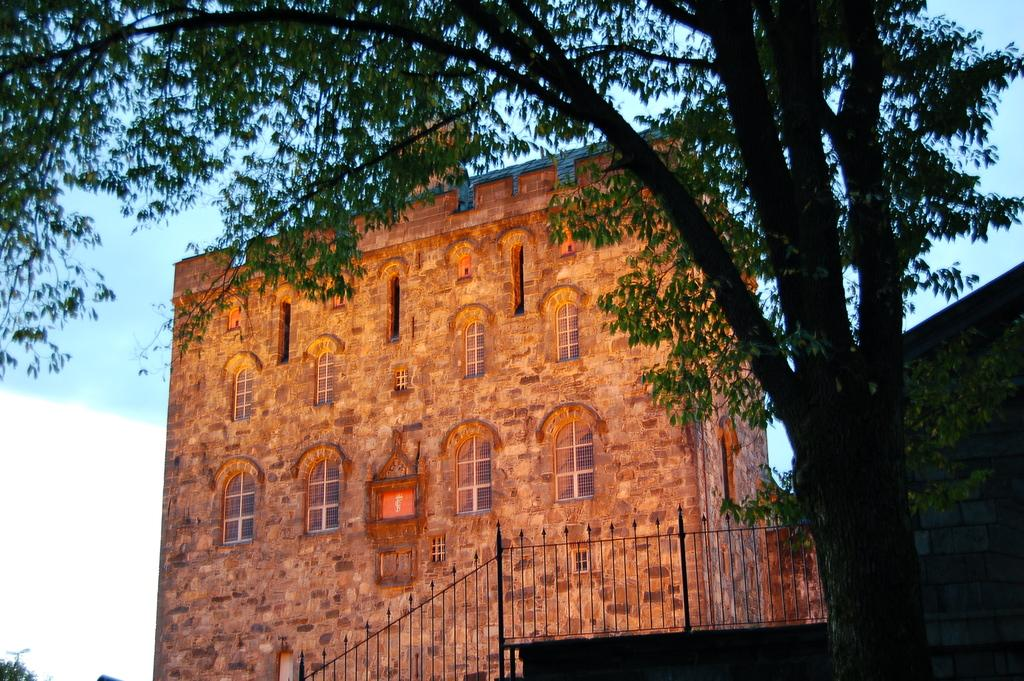What type of structure is present in the image? There is a building in the image. What other natural elements can be seen in the image? There are trees in the image. Is there any residential structure in the image? Yes, there is a house on the side in the image. What type of barrier is present in the image? There is a metal fence in the image. How would you describe the weather in the image? The sky is cloudy in the image. What type of lighting is present in the image? There is a pole light in the image. What type of power does the nerve have in the image? There is no mention of power or nerves in the image; it features a building, trees, a house, a metal fence, a cloudy sky, and a pole light. 